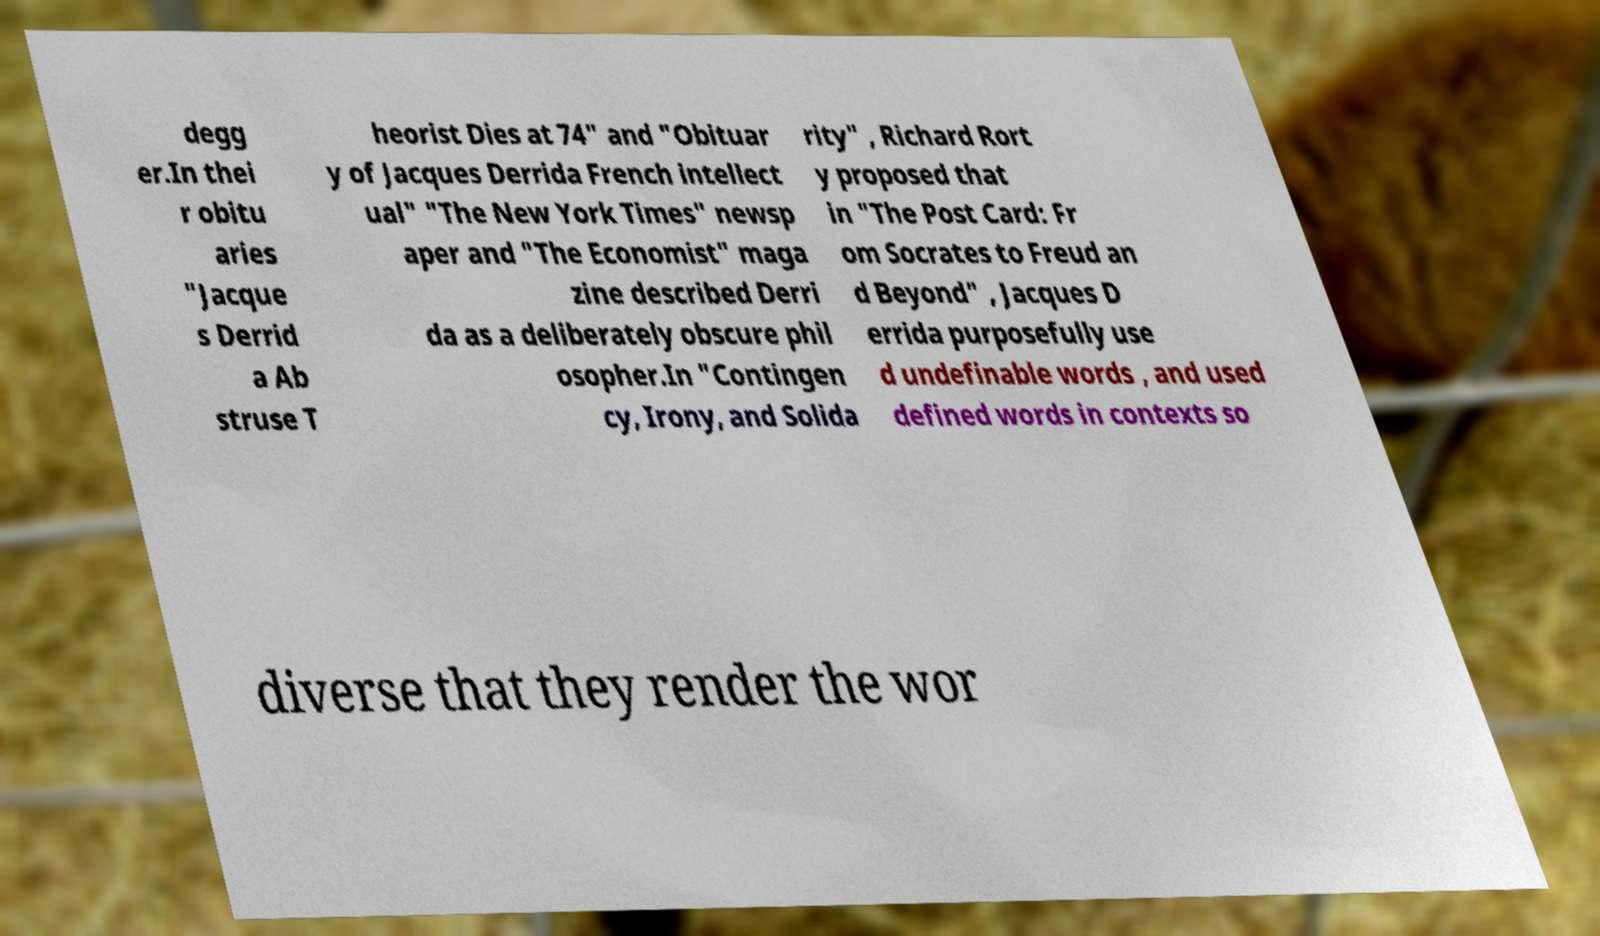Could you extract and type out the text from this image? degg er.In thei r obitu aries "Jacque s Derrid a Ab struse T heorist Dies at 74" and "Obituar y of Jacques Derrida French intellect ual" "The New York Times" newsp aper and "The Economist" maga zine described Derri da as a deliberately obscure phil osopher.In "Contingen cy, Irony, and Solida rity" , Richard Rort y proposed that in "The Post Card: Fr om Socrates to Freud an d Beyond" , Jacques D errida purposefully use d undefinable words , and used defined words in contexts so diverse that they render the wor 